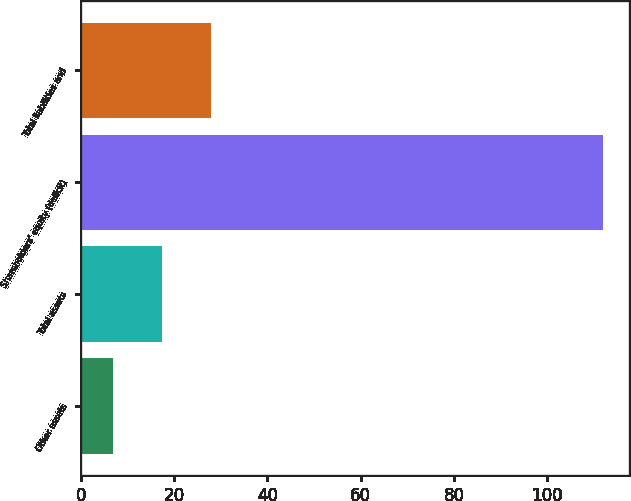Convert chart. <chart><loc_0><loc_0><loc_500><loc_500><bar_chart><fcel>Other assets<fcel>Total assets<fcel>Shareholders' equity (deficit)<fcel>Total liabilities and<nl><fcel>7<fcel>17.5<fcel>112<fcel>28<nl></chart> 